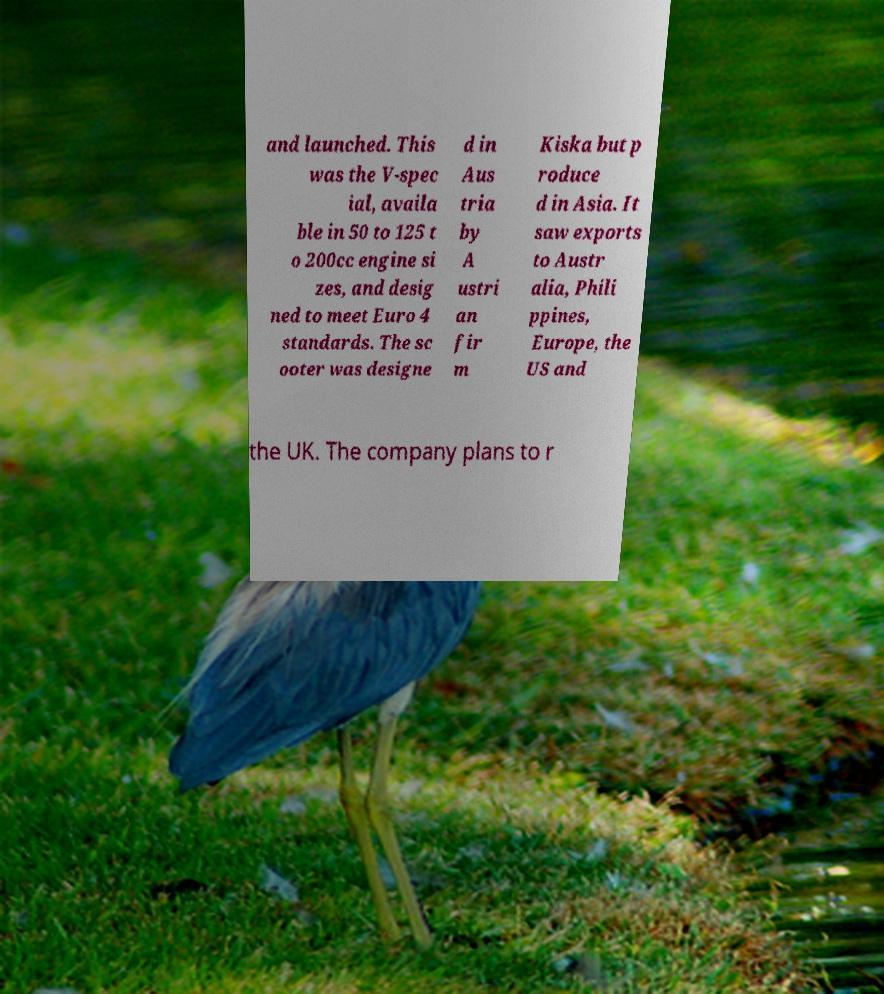What messages or text are displayed in this image? I need them in a readable, typed format. and launched. This was the V-spec ial, availa ble in 50 to 125 t o 200cc engine si zes, and desig ned to meet Euro 4 standards. The sc ooter was designe d in Aus tria by A ustri an fir m Kiska but p roduce d in Asia. It saw exports to Austr alia, Phili ppines, Europe, the US and the UK. The company plans to r 